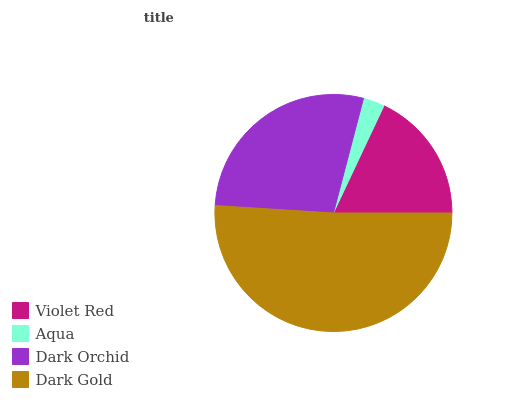Is Aqua the minimum?
Answer yes or no. Yes. Is Dark Gold the maximum?
Answer yes or no. Yes. Is Dark Orchid the minimum?
Answer yes or no. No. Is Dark Orchid the maximum?
Answer yes or no. No. Is Dark Orchid greater than Aqua?
Answer yes or no. Yes. Is Aqua less than Dark Orchid?
Answer yes or no. Yes. Is Aqua greater than Dark Orchid?
Answer yes or no. No. Is Dark Orchid less than Aqua?
Answer yes or no. No. Is Dark Orchid the high median?
Answer yes or no. Yes. Is Violet Red the low median?
Answer yes or no. Yes. Is Violet Red the high median?
Answer yes or no. No. Is Aqua the low median?
Answer yes or no. No. 